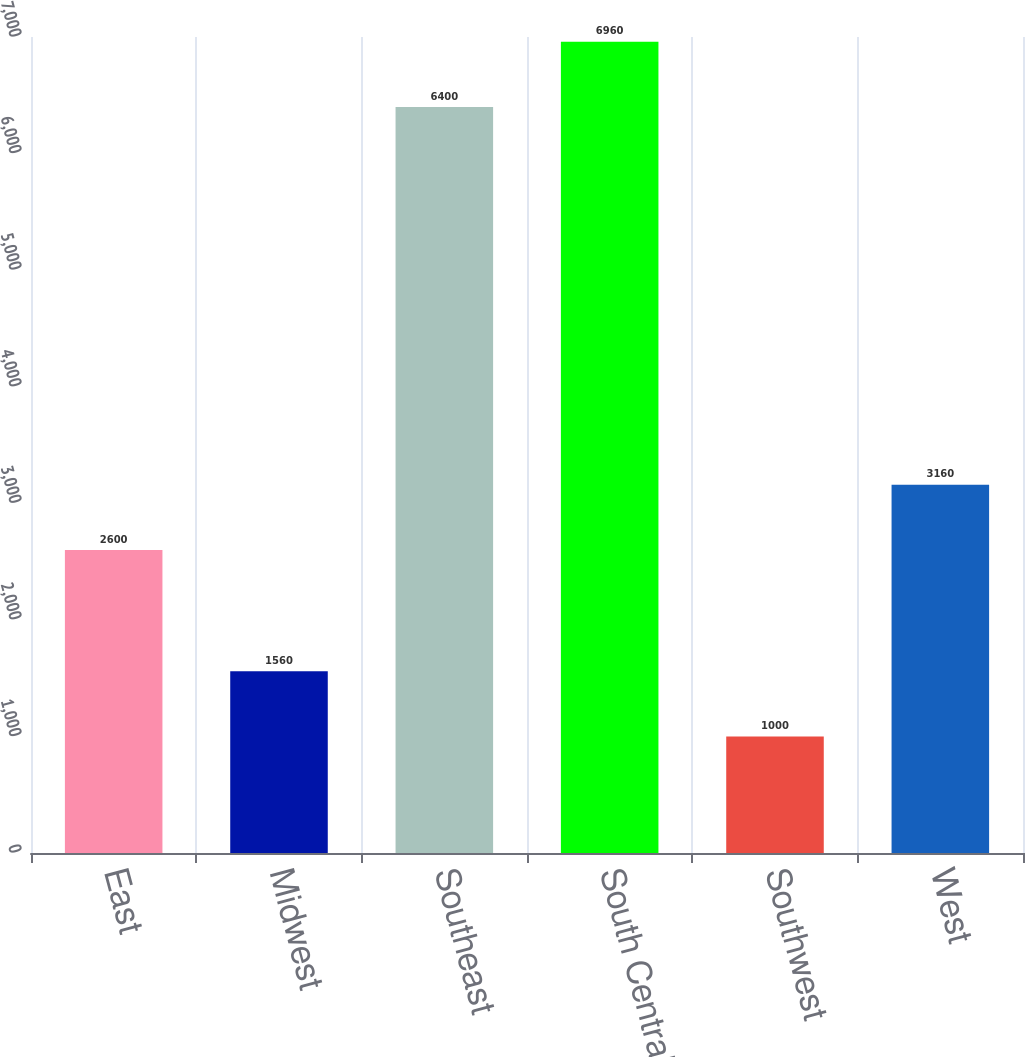Convert chart. <chart><loc_0><loc_0><loc_500><loc_500><bar_chart><fcel>East<fcel>Midwest<fcel>Southeast<fcel>South Central<fcel>Southwest<fcel>West<nl><fcel>2600<fcel>1560<fcel>6400<fcel>6960<fcel>1000<fcel>3160<nl></chart> 